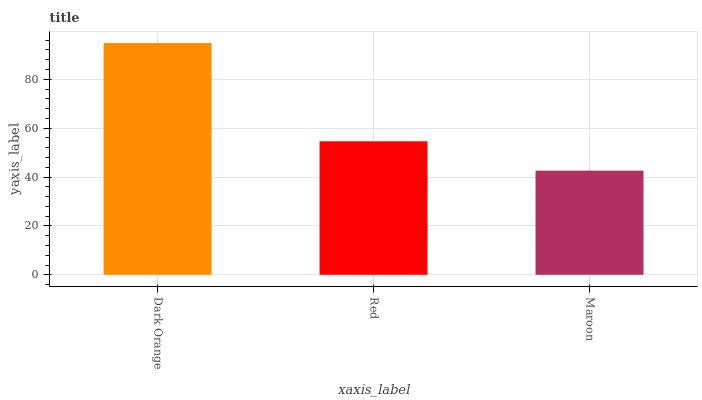Is Maroon the minimum?
Answer yes or no. Yes. Is Dark Orange the maximum?
Answer yes or no. Yes. Is Red the minimum?
Answer yes or no. No. Is Red the maximum?
Answer yes or no. No. Is Dark Orange greater than Red?
Answer yes or no. Yes. Is Red less than Dark Orange?
Answer yes or no. Yes. Is Red greater than Dark Orange?
Answer yes or no. No. Is Dark Orange less than Red?
Answer yes or no. No. Is Red the high median?
Answer yes or no. Yes. Is Red the low median?
Answer yes or no. Yes. Is Dark Orange the high median?
Answer yes or no. No. Is Maroon the low median?
Answer yes or no. No. 